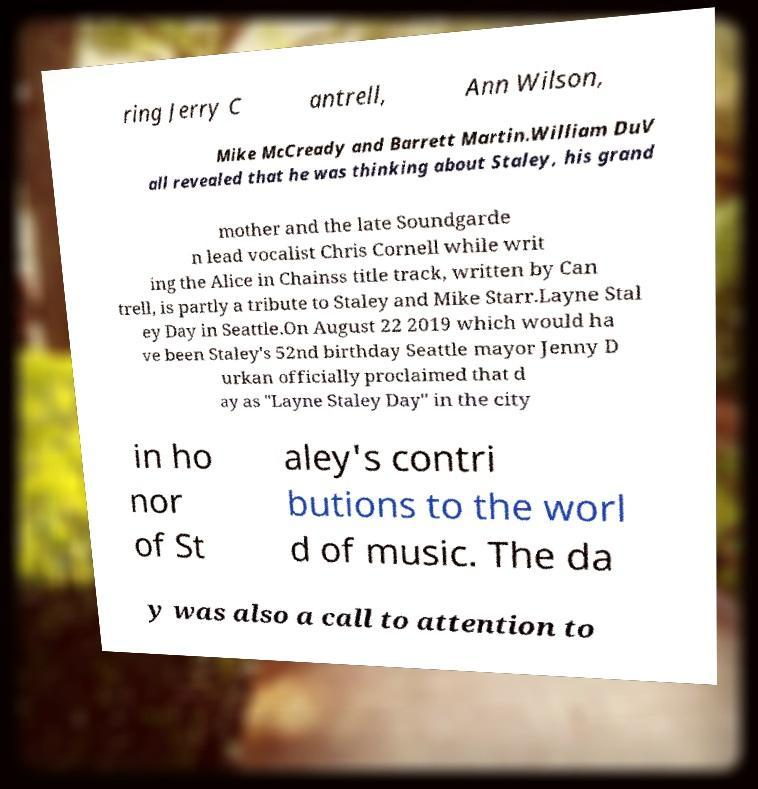Please read and relay the text visible in this image. What does it say? ring Jerry C antrell, Ann Wilson, Mike McCready and Barrett Martin.William DuV all revealed that he was thinking about Staley, his grand mother and the late Soundgarde n lead vocalist Chris Cornell while writ ing the Alice in Chainss title track, written by Can trell, is partly a tribute to Staley and Mike Starr.Layne Stal ey Day in Seattle.On August 22 2019 which would ha ve been Staley's 52nd birthday Seattle mayor Jenny D urkan officially proclaimed that d ay as "Layne Staley Day" in the city in ho nor of St aley's contri butions to the worl d of music. The da y was also a call to attention to 